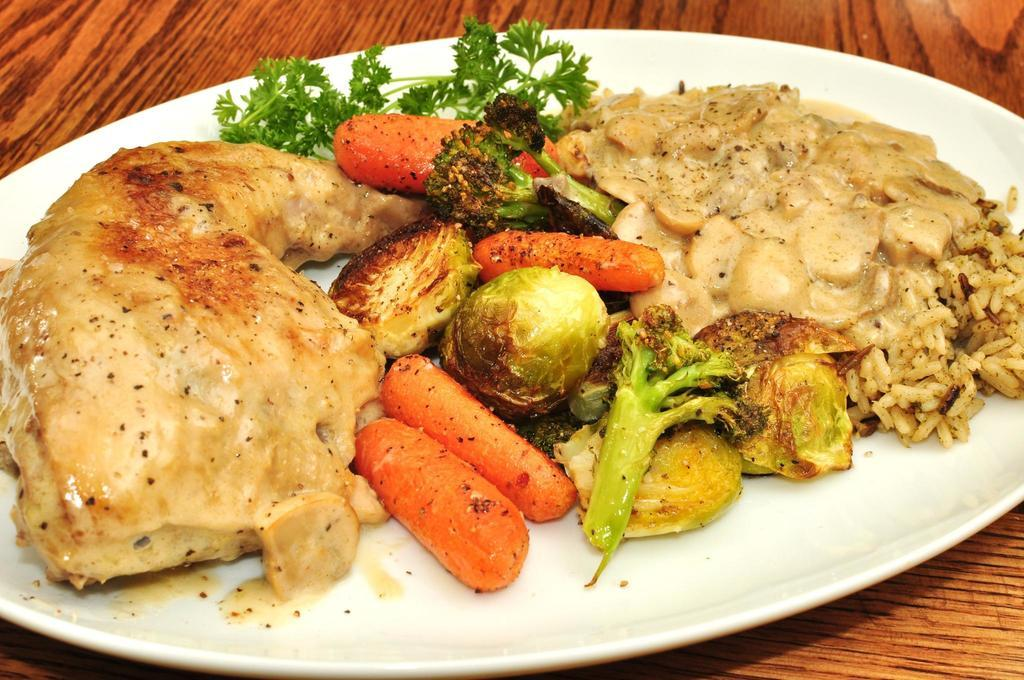What is on the table in the image? There is a white plate on the table. What types of food are on the white plate? The white plate contains meat, bread, carrot, cabbage, rice, and mince. Are there any other food items on the white plate? Yes, there are other food items on the white plate. What type of brush is used to clean the train in the image? There is no train or brush present in the image; it features a white plate with various food items. 